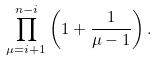<formula> <loc_0><loc_0><loc_500><loc_500>\prod _ { \mu = i + 1 } ^ { n - i } \left ( 1 + \frac { 1 } { \mu - 1 } \right ) .</formula> 